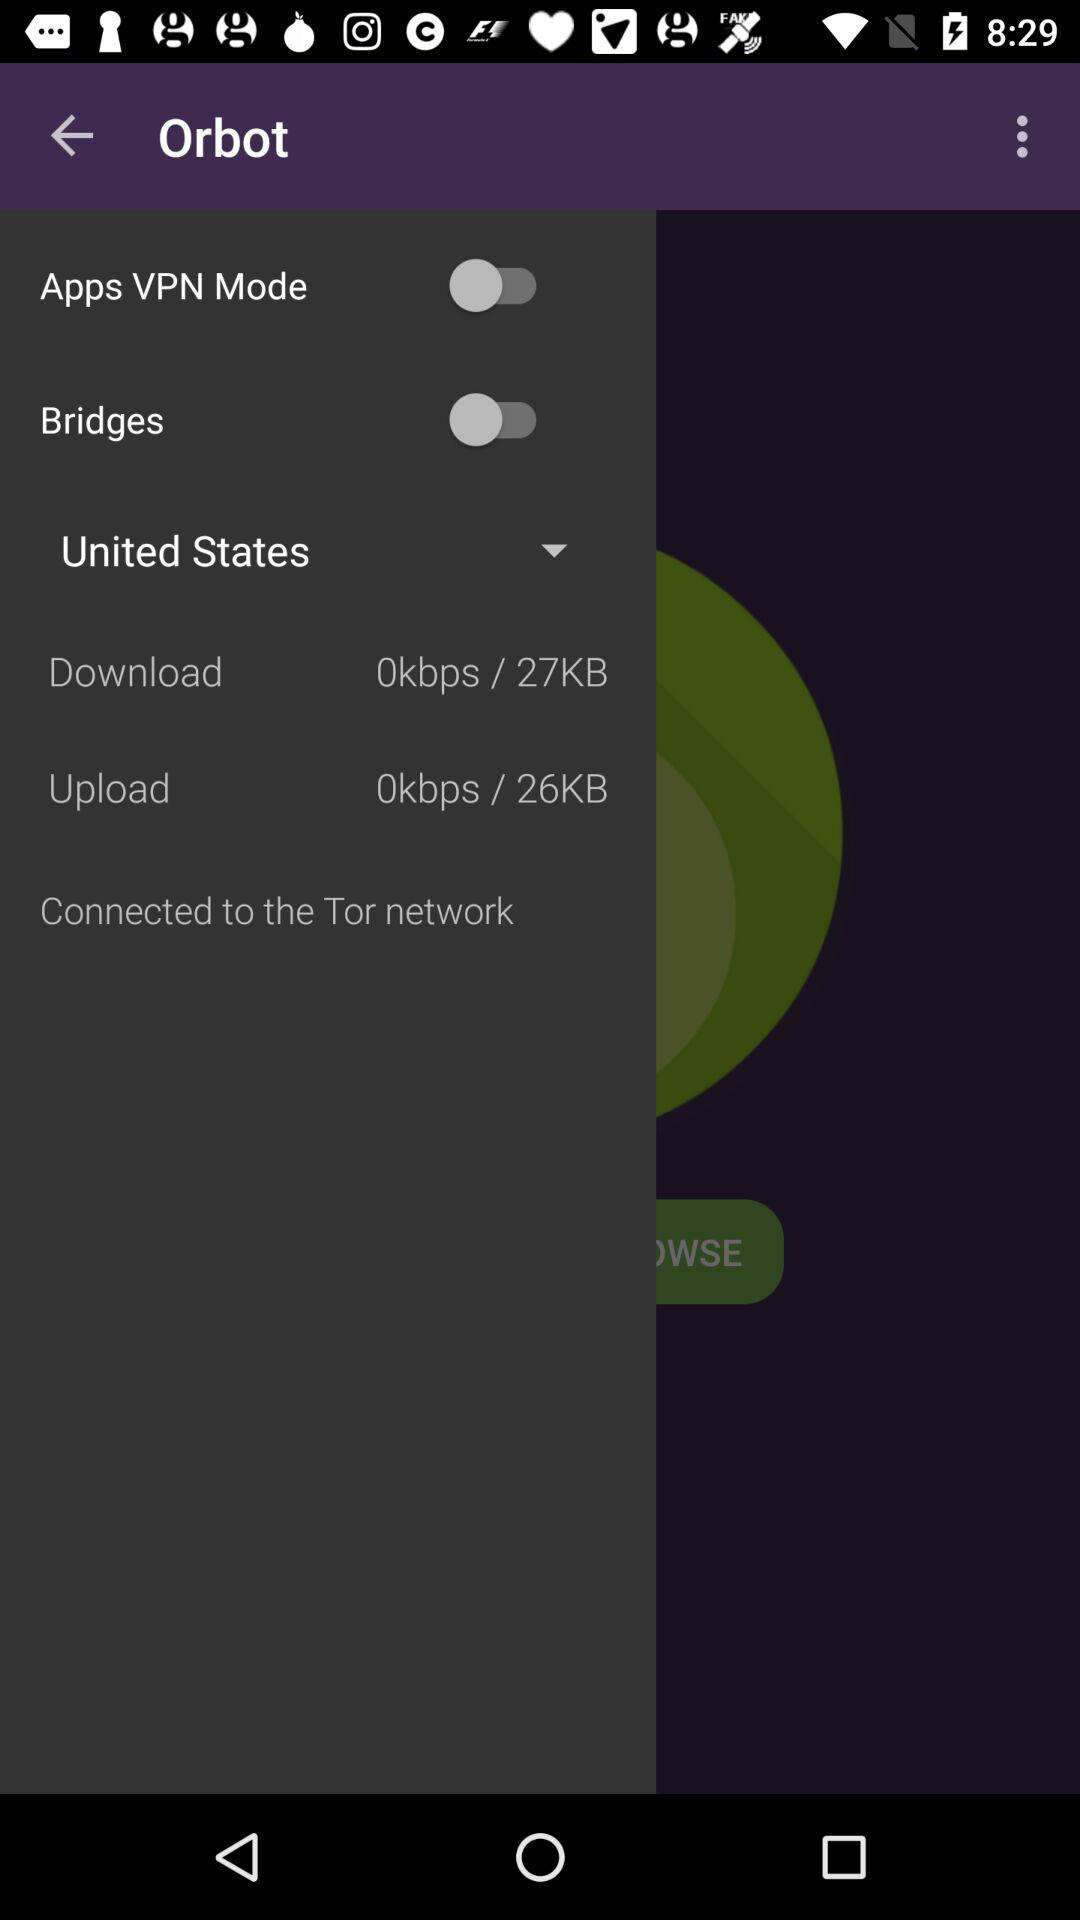Which mode is selected for Bridges?
When the provided information is insufficient, respond with <no answer>. <no answer> 